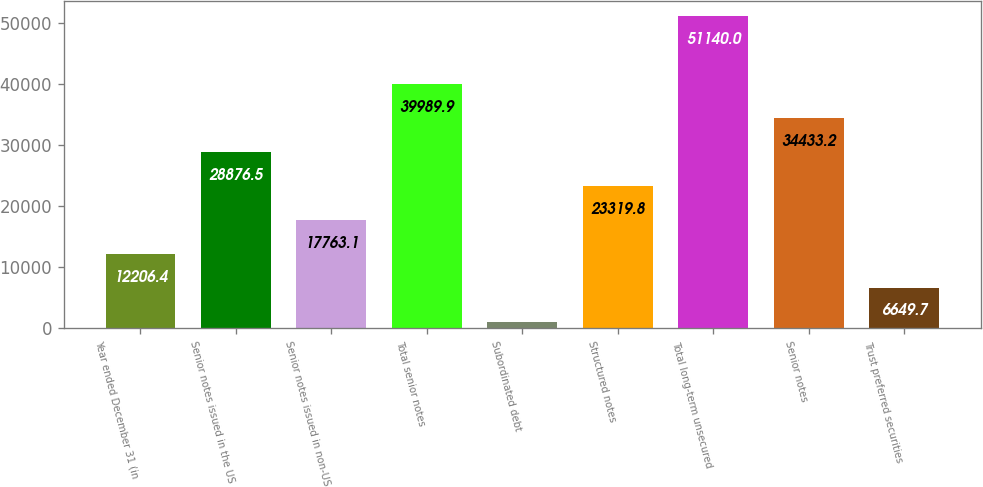Convert chart. <chart><loc_0><loc_0><loc_500><loc_500><bar_chart><fcel>Year ended December 31 (in<fcel>Senior notes issued in the US<fcel>Senior notes issued in non-US<fcel>Total senior notes<fcel>Subordinated debt<fcel>Structured notes<fcel>Total long-term unsecured<fcel>Senior notes<fcel>Trust preferred securities<nl><fcel>12206.4<fcel>28876.5<fcel>17763.1<fcel>39989.9<fcel>1093<fcel>23319.8<fcel>51140<fcel>34433.2<fcel>6649.7<nl></chart> 